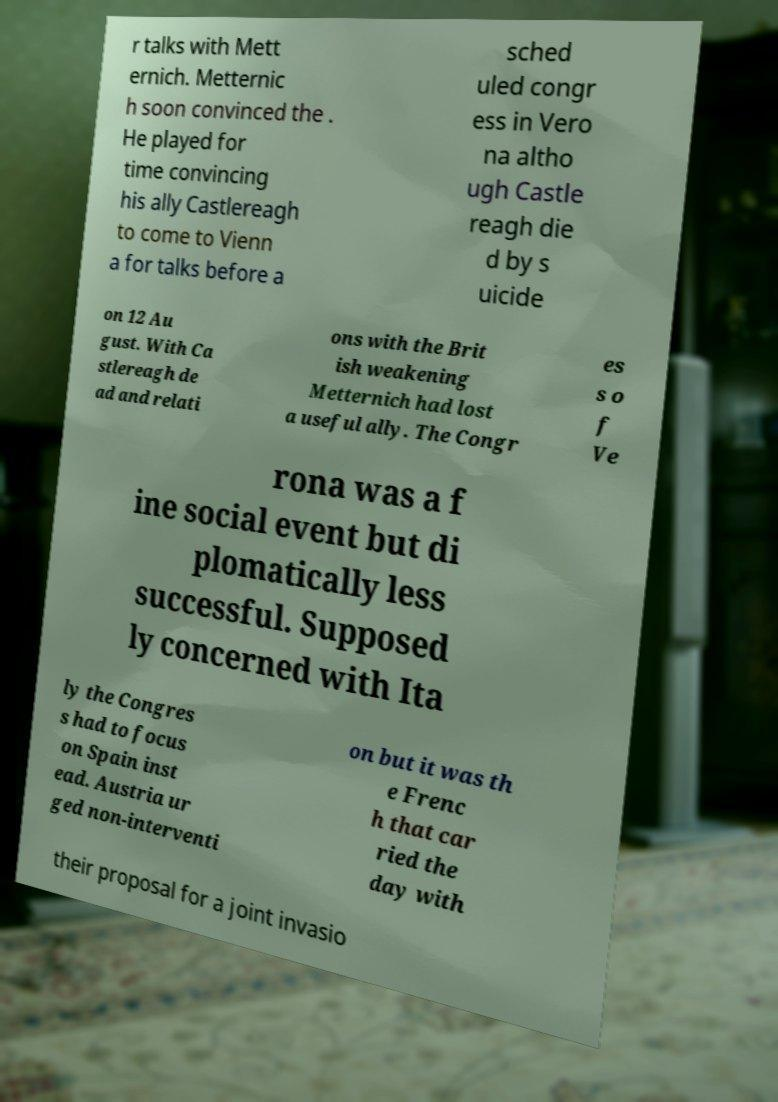Can you read and provide the text displayed in the image?This photo seems to have some interesting text. Can you extract and type it out for me? r talks with Mett ernich. Metternic h soon convinced the . He played for time convincing his ally Castlereagh to come to Vienn a for talks before a sched uled congr ess in Vero na altho ugh Castle reagh die d by s uicide on 12 Au gust. With Ca stlereagh de ad and relati ons with the Brit ish weakening Metternich had lost a useful ally. The Congr es s o f Ve rona was a f ine social event but di plomatically less successful. Supposed ly concerned with Ita ly the Congres s had to focus on Spain inst ead. Austria ur ged non-interventi on but it was th e Frenc h that car ried the day with their proposal for a joint invasio 